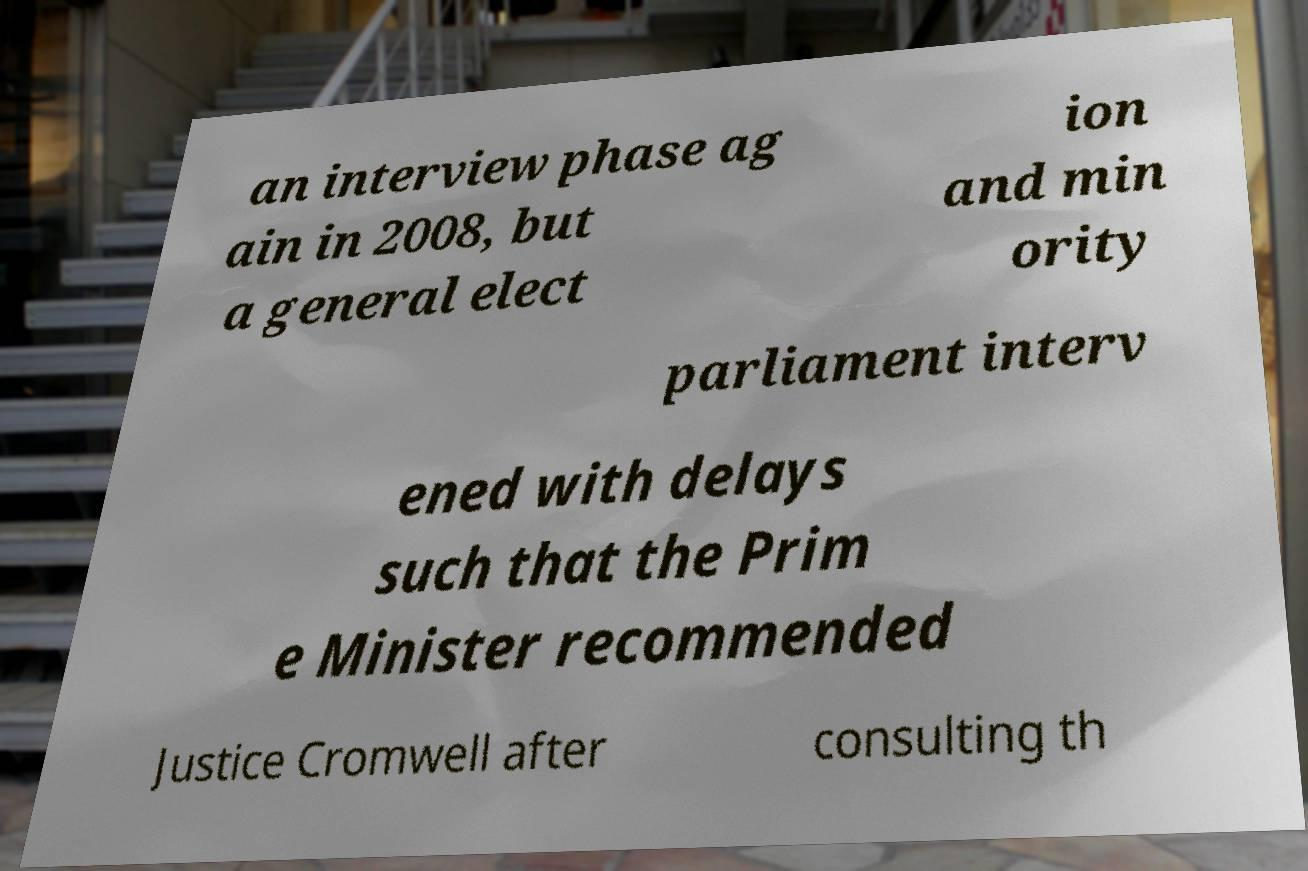Can you accurately transcribe the text from the provided image for me? an interview phase ag ain in 2008, but a general elect ion and min ority parliament interv ened with delays such that the Prim e Minister recommended Justice Cromwell after consulting th 